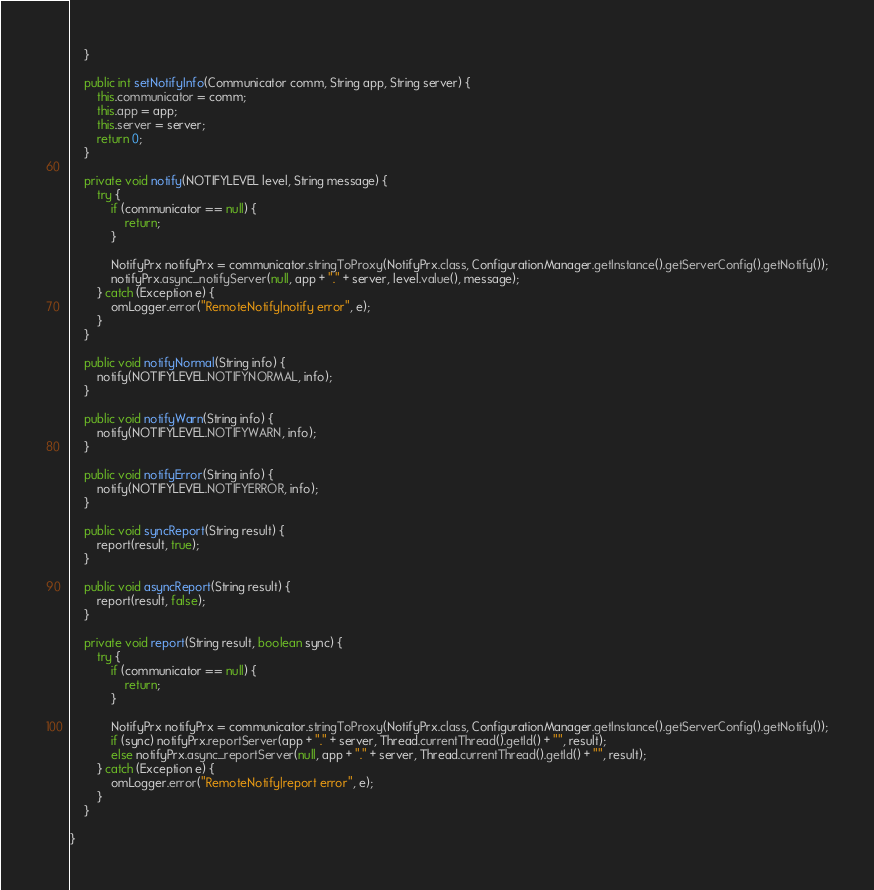Convert code to text. <code><loc_0><loc_0><loc_500><loc_500><_Java_>    }

    public int setNotifyInfo(Communicator comm, String app, String server) {
        this.communicator = comm;
        this.app = app;
        this.server = server;
        return 0;
    }

    private void notify(NOTIFYLEVEL level, String message) {
        try {
            if (communicator == null) {
                return;
            }

            NotifyPrx notifyPrx = communicator.stringToProxy(NotifyPrx.class, ConfigurationManager.getInstance().getServerConfig().getNotify());
            notifyPrx.async_notifyServer(null, app + "." + server, level.value(), message);
        } catch (Exception e) {
            omLogger.error("RemoteNotify|notify error", e);
        }
    }

    public void notifyNormal(String info) {
        notify(NOTIFYLEVEL.NOTIFYNORMAL, info);
    }

    public void notifyWarn(String info) {
        notify(NOTIFYLEVEL.NOTIFYWARN, info);
    }

    public void notifyError(String info) {
        notify(NOTIFYLEVEL.NOTIFYERROR, info);
    }

    public void syncReport(String result) {
        report(result, true);
    }

    public void asyncReport(String result) {
        report(result, false);
    }

    private void report(String result, boolean sync) {
        try {
            if (communicator == null) {
                return;
            }

            NotifyPrx notifyPrx = communicator.stringToProxy(NotifyPrx.class, ConfigurationManager.getInstance().getServerConfig().getNotify());
            if (sync) notifyPrx.reportServer(app + "." + server, Thread.currentThread().getId() + "", result);
            else notifyPrx.async_reportServer(null, app + "." + server, Thread.currentThread().getId() + "", result);
        } catch (Exception e) {
            omLogger.error("RemoteNotify|report error", e);
        }
    }

}
</code> 